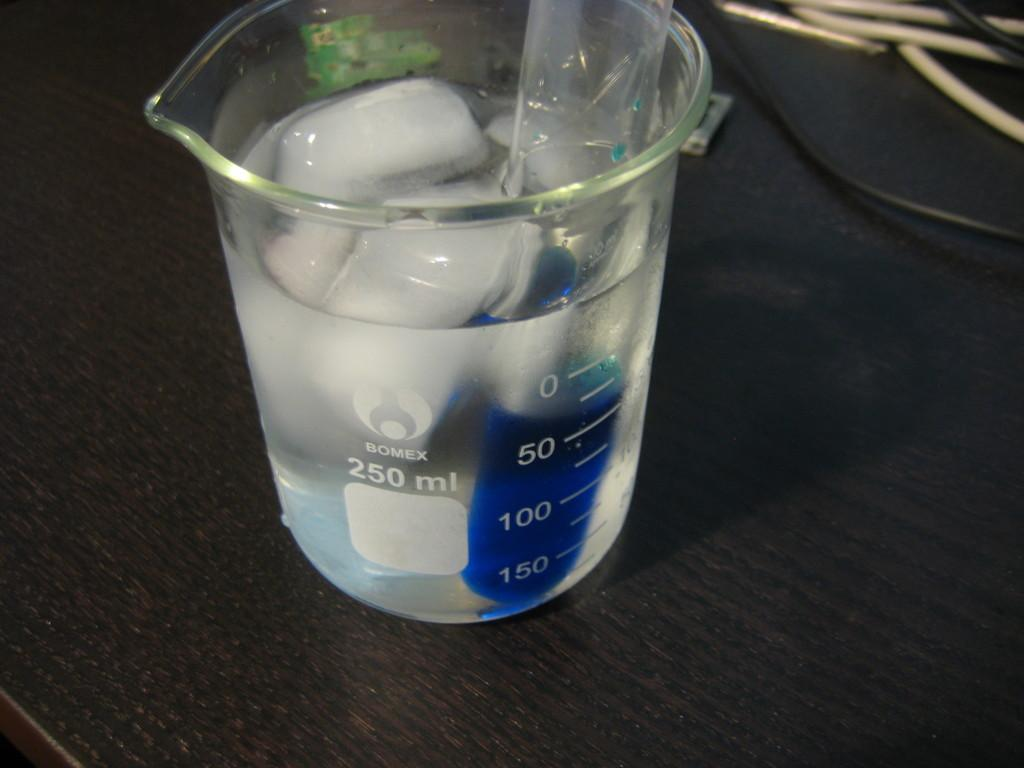<image>
Write a terse but informative summary of the picture. A 250 ml beaker with ice and liquid and a blue substance in a test tube sits on a table. 